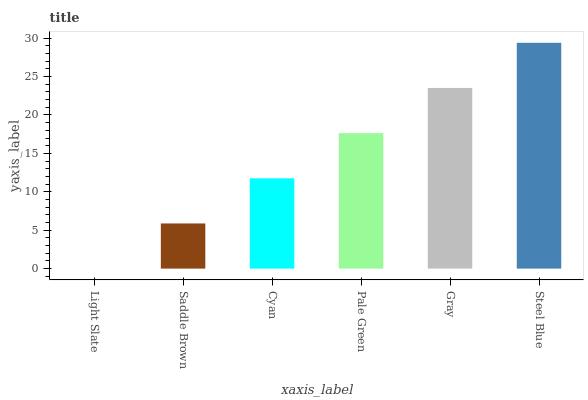Is Saddle Brown the minimum?
Answer yes or no. No. Is Saddle Brown the maximum?
Answer yes or no. No. Is Saddle Brown greater than Light Slate?
Answer yes or no. Yes. Is Light Slate less than Saddle Brown?
Answer yes or no. Yes. Is Light Slate greater than Saddle Brown?
Answer yes or no. No. Is Saddle Brown less than Light Slate?
Answer yes or no. No. Is Pale Green the high median?
Answer yes or no. Yes. Is Cyan the low median?
Answer yes or no. Yes. Is Light Slate the high median?
Answer yes or no. No. Is Pale Green the low median?
Answer yes or no. No. 